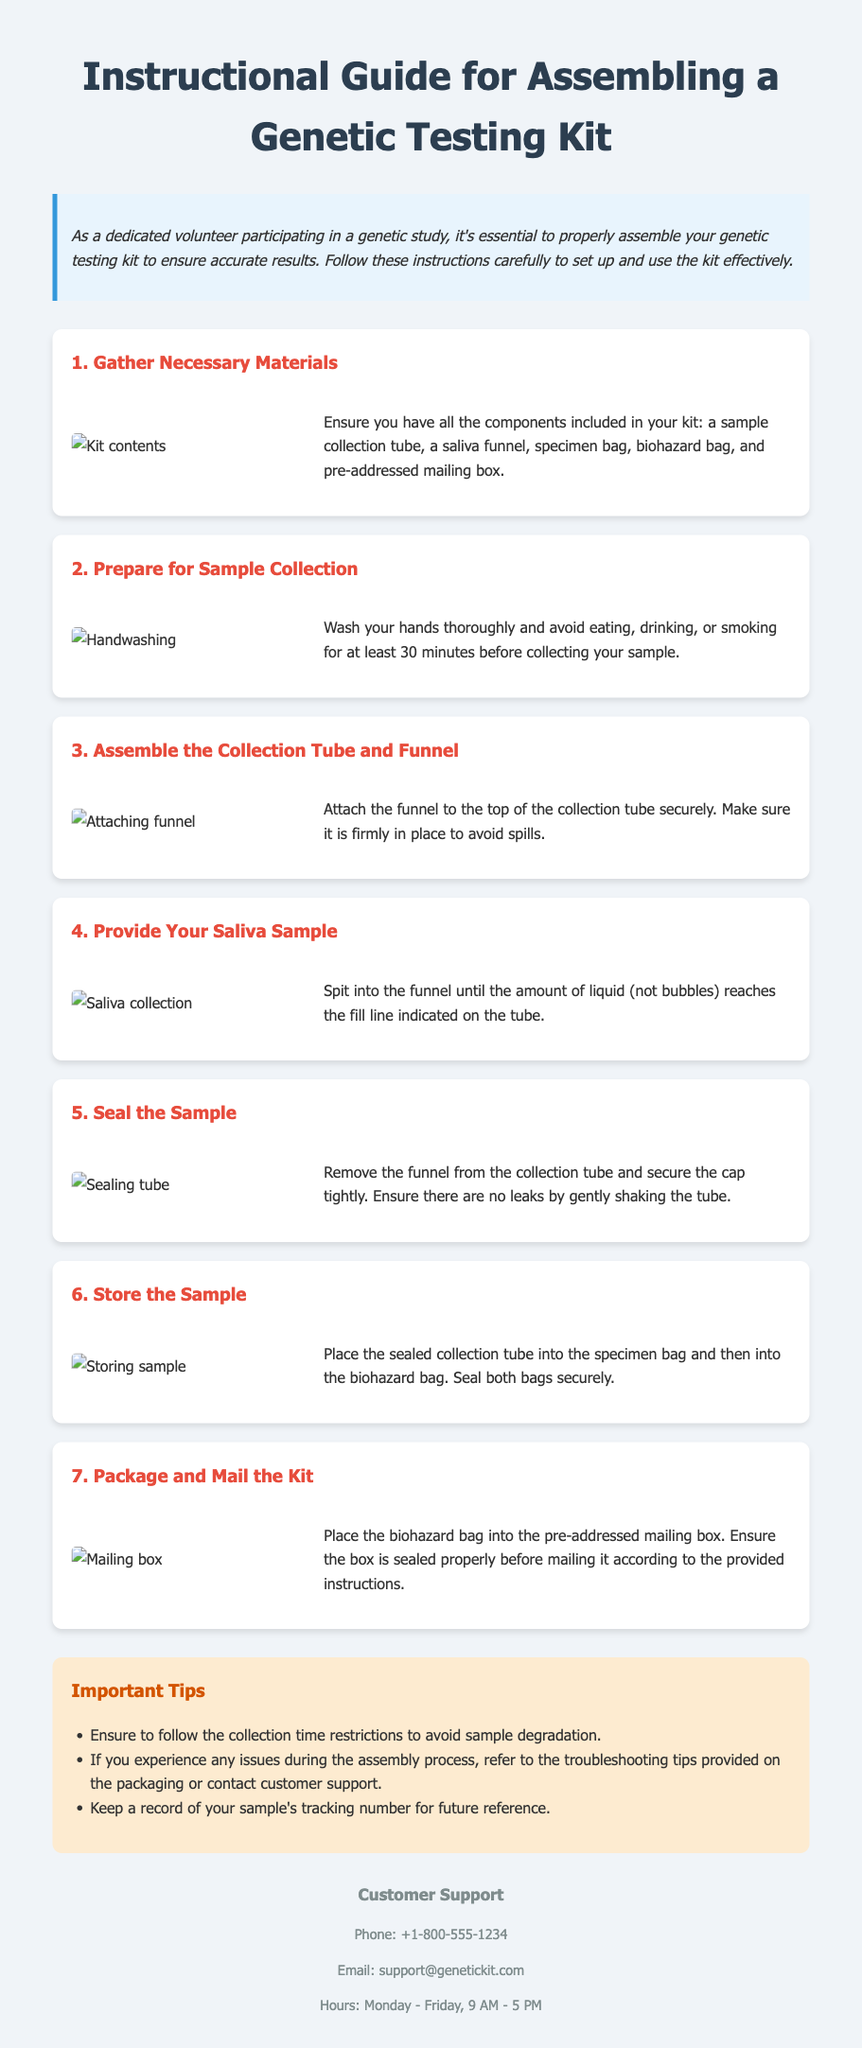what is the first step in assembling the genetic testing kit? The first step outlined in the document is to "Gather Necessary Materials" which includes all essential components for the kit.
Answer: Gather Necessary Materials how many elements are included in the kit? The document specifies the components included in the kit, which are five: a sample collection tube, a saliva funnel, a specimen bag, a biohazard bag, and a pre-addressed mailing box.
Answer: Five what should you avoid doing before collecting your sample? The instructions mention that you should avoid "eating, drinking, or smoking" for at least 30 minutes prior to sample collection.
Answer: Eating, drinking, or smoking what is the purpose of sealing the sample? The purpose of sealing the sample is to "ensure there are no leaks" and to maintain the integrity of the sample during transportation.
Answer: Ensure there are no leaks which bag should the sealed collection tube be placed into after sealing? The sealed collection tube should be placed into the "specimen bag" after it has been secured with the cap.
Answer: Specimen bag what must you keep a record of regarding your sample? It is advised to keep a record of your sample's "tracking number" for future reference.
Answer: Tracking number what color is the tips section background? The background color of the tips section is "light orange," indicated by its description in the document.
Answer: Light orange what is the customer support phone number? The document provides the customer support phone number as "+1-800-555-1234."
Answer: +1-800-555-1234 